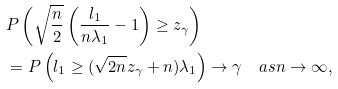<formula> <loc_0><loc_0><loc_500><loc_500>& P \left ( \sqrt { \frac { n } { 2 } } \left ( \frac { l _ { 1 } } { n \lambda _ { 1 } } - 1 \right ) \geq z _ { \gamma } \right ) \\ & = P \left ( l _ { 1 } \geq ( \sqrt { 2 n } z _ { \gamma } + n ) \lambda _ { 1 } \right ) \rightarrow \gamma \quad a s n \rightarrow \infty ,</formula> 